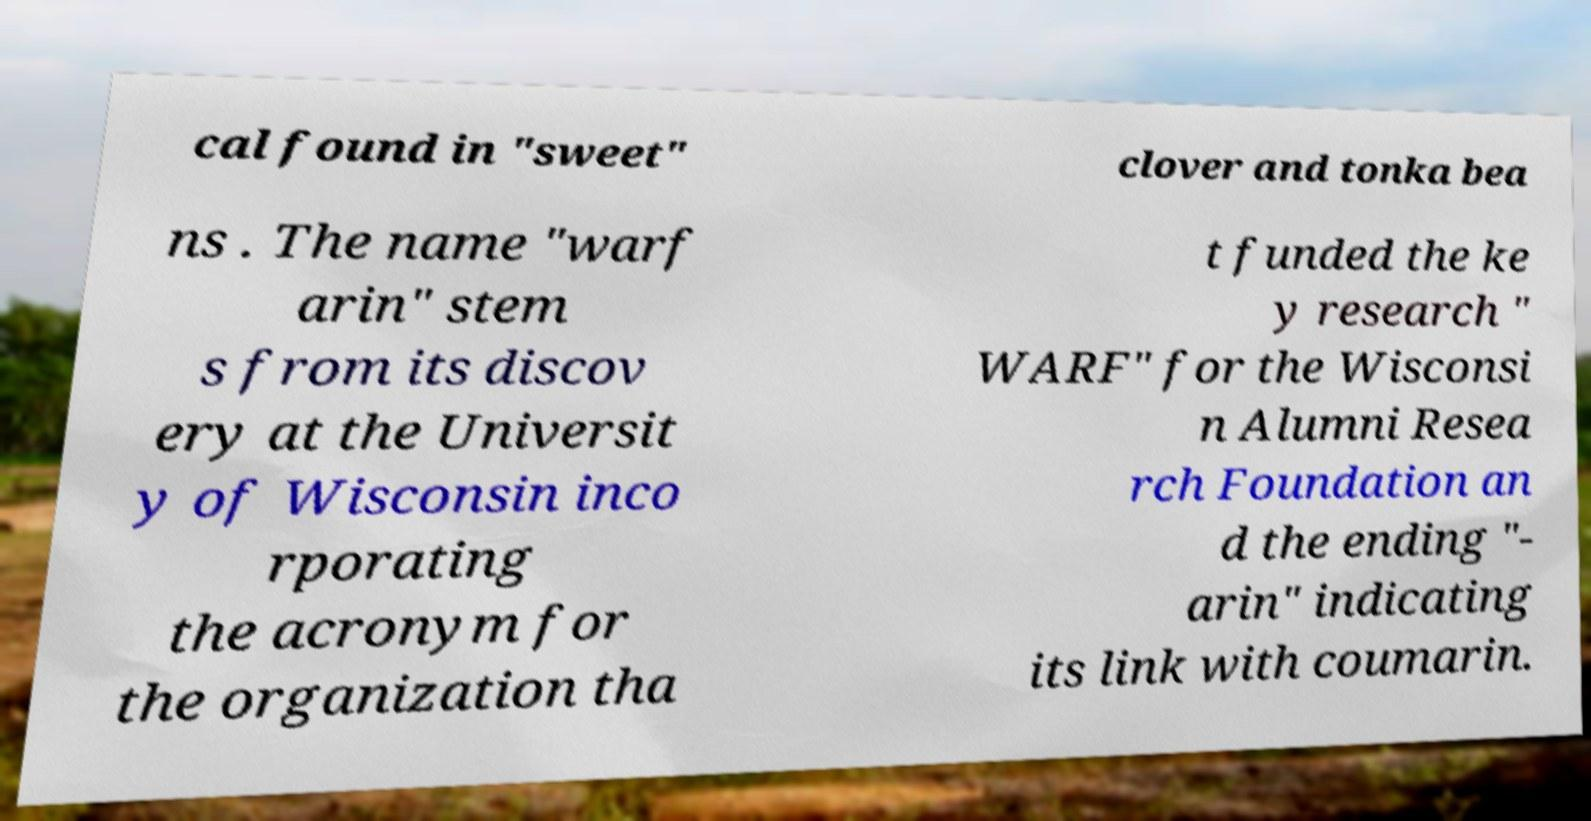Could you extract and type out the text from this image? cal found in "sweet" clover and tonka bea ns . The name "warf arin" stem s from its discov ery at the Universit y of Wisconsin inco rporating the acronym for the organization tha t funded the ke y research " WARF" for the Wisconsi n Alumni Resea rch Foundation an d the ending "- arin" indicating its link with coumarin. 